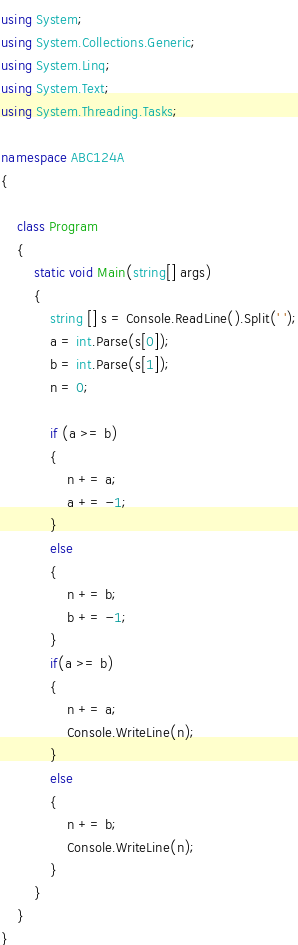<code> <loc_0><loc_0><loc_500><loc_500><_C#_>using System;
using System.Collections.Generic;
using System.Linq;
using System.Text;
using System.Threading.Tasks;

namespace ABC124A
{
   
    class Program
    {
        static void Main(string[] args)
        {
            string [] s = Console.ReadLine().Split(' ');
            a = int.Parse(s[0]);
            b = int.Parse(s[1]);
            n = 0;

            if (a >= b)
            {
                n += a;
                a += -1;
            }
            else
            {
                n += b;
                b += -1;
            }
            if(a >= b)
            {
                n += a;
                Console.WriteLine(n);
            }
            else
            {
                n += b;
                Console.WriteLine(n);
            }
        }
    }
}
</code> 